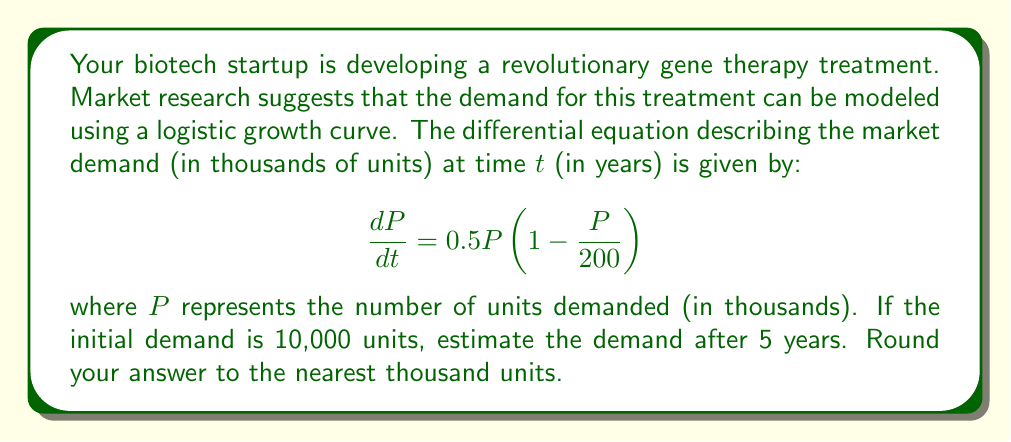Show me your answer to this math problem. To solve this problem, we need to use the solution to the logistic differential equation. The general form of the logistic equation is:

$$\frac{dP}{dt} = rP(1 - \frac{P}{K})$$

where r is the growth rate and K is the carrying capacity.

In our case, r = 0.5 and K = 200 (thousand units).

The solution to this differential equation is:

$$P(t) = \frac{K}{1 + (\frac{K}{P_0} - 1)e^{-rt}}$$

where P₀ is the initial population.

Given:
- K = 200 (thousand units)
- r = 0.5
- P₀ = 10 (thousand units)
- t = 5 years

Let's substitute these values into the equation:

$$P(5) = \frac{200}{1 + (\frac{200}{10} - 1)e^{-0.5(5)}}$$

$$P(5) = \frac{200}{1 + 19e^{-2.5}}$$

Now, let's calculate this step by step:
1. Calculate e⁻²·⁵ ≈ 0.0821
2. Multiply: 19 × 0.0821 ≈ 1.5599
3. Add 1: 1 + 1.5599 = 2.5599
4. Divide: 200 ÷ 2.5599 ≈ 78.1281

Therefore, P(5) ≈ 78.1281 thousand units.

Rounding to the nearest thousand, we get 78,000 units.
Answer: 78,000 units 